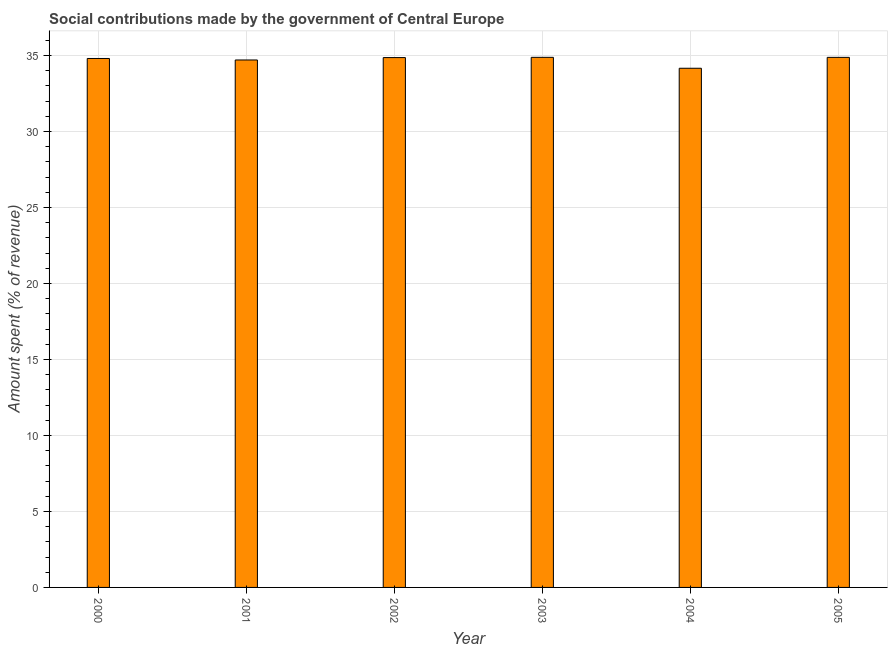Does the graph contain any zero values?
Offer a very short reply. No. What is the title of the graph?
Offer a terse response. Social contributions made by the government of Central Europe. What is the label or title of the X-axis?
Provide a short and direct response. Year. What is the label or title of the Y-axis?
Your answer should be very brief. Amount spent (% of revenue). What is the amount spent in making social contributions in 2003?
Provide a short and direct response. 34.89. Across all years, what is the maximum amount spent in making social contributions?
Give a very brief answer. 34.89. Across all years, what is the minimum amount spent in making social contributions?
Your answer should be compact. 34.17. In which year was the amount spent in making social contributions maximum?
Provide a succinct answer. 2003. In which year was the amount spent in making social contributions minimum?
Your answer should be compact. 2004. What is the sum of the amount spent in making social contributions?
Your response must be concise. 208.33. What is the difference between the amount spent in making social contributions in 2003 and 2004?
Your response must be concise. 0.72. What is the average amount spent in making social contributions per year?
Ensure brevity in your answer.  34.72. What is the median amount spent in making social contributions?
Provide a short and direct response. 34.84. In how many years, is the amount spent in making social contributions greater than 12 %?
Offer a terse response. 6. Is the amount spent in making social contributions in 2002 less than that in 2004?
Give a very brief answer. No. Is the difference between the amount spent in making social contributions in 2001 and 2003 greater than the difference between any two years?
Offer a very short reply. No. What is the difference between the highest and the second highest amount spent in making social contributions?
Make the answer very short. 0. What is the difference between the highest and the lowest amount spent in making social contributions?
Keep it short and to the point. 0.72. In how many years, is the amount spent in making social contributions greater than the average amount spent in making social contributions taken over all years?
Keep it short and to the point. 4. How many bars are there?
Provide a short and direct response. 6. Are all the bars in the graph horizontal?
Your answer should be very brief. No. How many years are there in the graph?
Your answer should be very brief. 6. What is the difference between two consecutive major ticks on the Y-axis?
Give a very brief answer. 5. What is the Amount spent (% of revenue) of 2000?
Keep it short and to the point. 34.81. What is the Amount spent (% of revenue) in 2001?
Your answer should be compact. 34.71. What is the Amount spent (% of revenue) in 2002?
Your response must be concise. 34.87. What is the Amount spent (% of revenue) in 2003?
Offer a terse response. 34.89. What is the Amount spent (% of revenue) in 2004?
Make the answer very short. 34.17. What is the Amount spent (% of revenue) in 2005?
Your answer should be compact. 34.88. What is the difference between the Amount spent (% of revenue) in 2000 and 2001?
Your answer should be compact. 0.1. What is the difference between the Amount spent (% of revenue) in 2000 and 2002?
Provide a succinct answer. -0.06. What is the difference between the Amount spent (% of revenue) in 2000 and 2003?
Give a very brief answer. -0.08. What is the difference between the Amount spent (% of revenue) in 2000 and 2004?
Your answer should be very brief. 0.64. What is the difference between the Amount spent (% of revenue) in 2000 and 2005?
Offer a very short reply. -0.07. What is the difference between the Amount spent (% of revenue) in 2001 and 2002?
Ensure brevity in your answer.  -0.16. What is the difference between the Amount spent (% of revenue) in 2001 and 2003?
Your answer should be very brief. -0.17. What is the difference between the Amount spent (% of revenue) in 2001 and 2004?
Provide a short and direct response. 0.55. What is the difference between the Amount spent (% of revenue) in 2001 and 2005?
Provide a short and direct response. -0.17. What is the difference between the Amount spent (% of revenue) in 2002 and 2003?
Give a very brief answer. -0.02. What is the difference between the Amount spent (% of revenue) in 2002 and 2004?
Ensure brevity in your answer.  0.7. What is the difference between the Amount spent (% of revenue) in 2002 and 2005?
Provide a short and direct response. -0.01. What is the difference between the Amount spent (% of revenue) in 2003 and 2004?
Your answer should be compact. 0.72. What is the difference between the Amount spent (% of revenue) in 2003 and 2005?
Your response must be concise. 0. What is the difference between the Amount spent (% of revenue) in 2004 and 2005?
Ensure brevity in your answer.  -0.72. What is the ratio of the Amount spent (% of revenue) in 2000 to that in 2001?
Offer a very short reply. 1. What is the ratio of the Amount spent (% of revenue) in 2000 to that in 2003?
Offer a terse response. 1. What is the ratio of the Amount spent (% of revenue) in 2000 to that in 2004?
Offer a very short reply. 1.02. What is the ratio of the Amount spent (% of revenue) in 2000 to that in 2005?
Ensure brevity in your answer.  1. What is the ratio of the Amount spent (% of revenue) in 2001 to that in 2002?
Give a very brief answer. 0.99. What is the ratio of the Amount spent (% of revenue) in 2001 to that in 2003?
Your answer should be very brief. 0.99. What is the ratio of the Amount spent (% of revenue) in 2001 to that in 2004?
Keep it short and to the point. 1.02. What is the ratio of the Amount spent (% of revenue) in 2002 to that in 2003?
Make the answer very short. 1. What is the ratio of the Amount spent (% of revenue) in 2002 to that in 2004?
Your answer should be very brief. 1.02. What is the ratio of the Amount spent (% of revenue) in 2002 to that in 2005?
Offer a terse response. 1. What is the ratio of the Amount spent (% of revenue) in 2004 to that in 2005?
Your answer should be very brief. 0.98. 